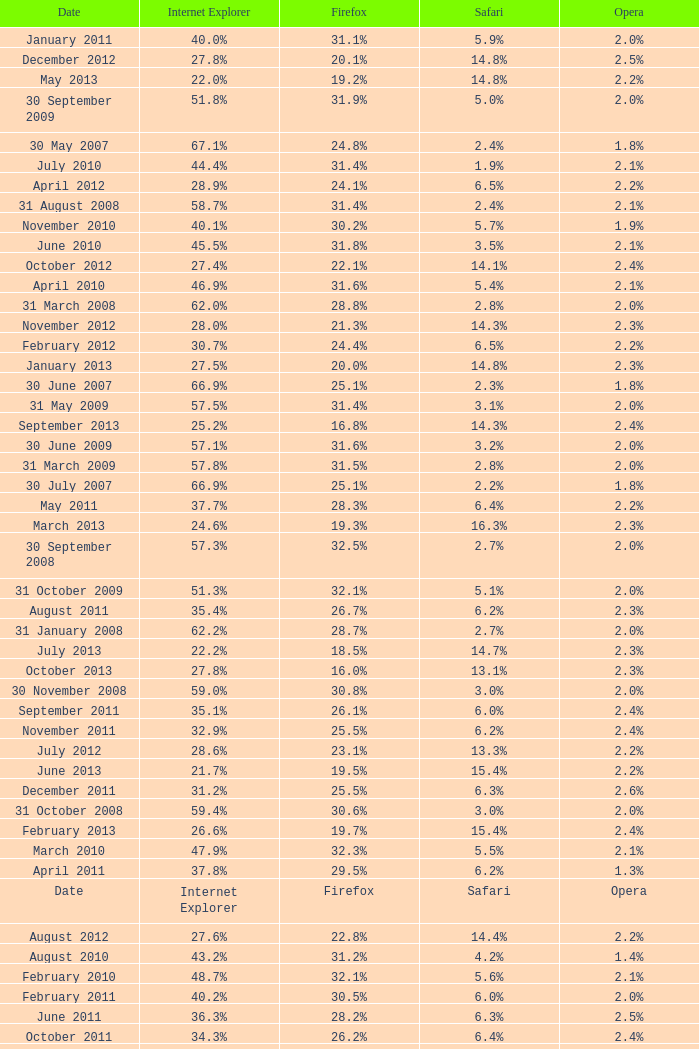What is the safari value with a 2.4% opera and 29.9% internet explorer? 6.5%. 